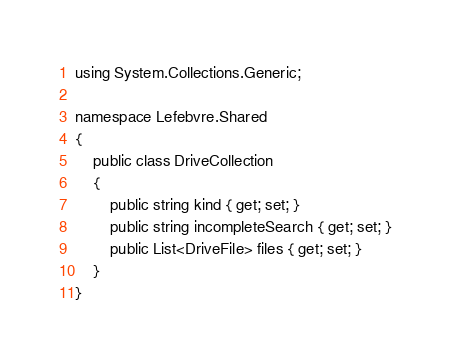Convert code to text. <code><loc_0><loc_0><loc_500><loc_500><_C#_>using System.Collections.Generic;

namespace Lefebvre.Shared
{
    public class DriveCollection
    {
        public string kind { get; set; }
        public string incompleteSearch { get; set; }
        public List<DriveFile> files { get; set; }
    }
}</code> 